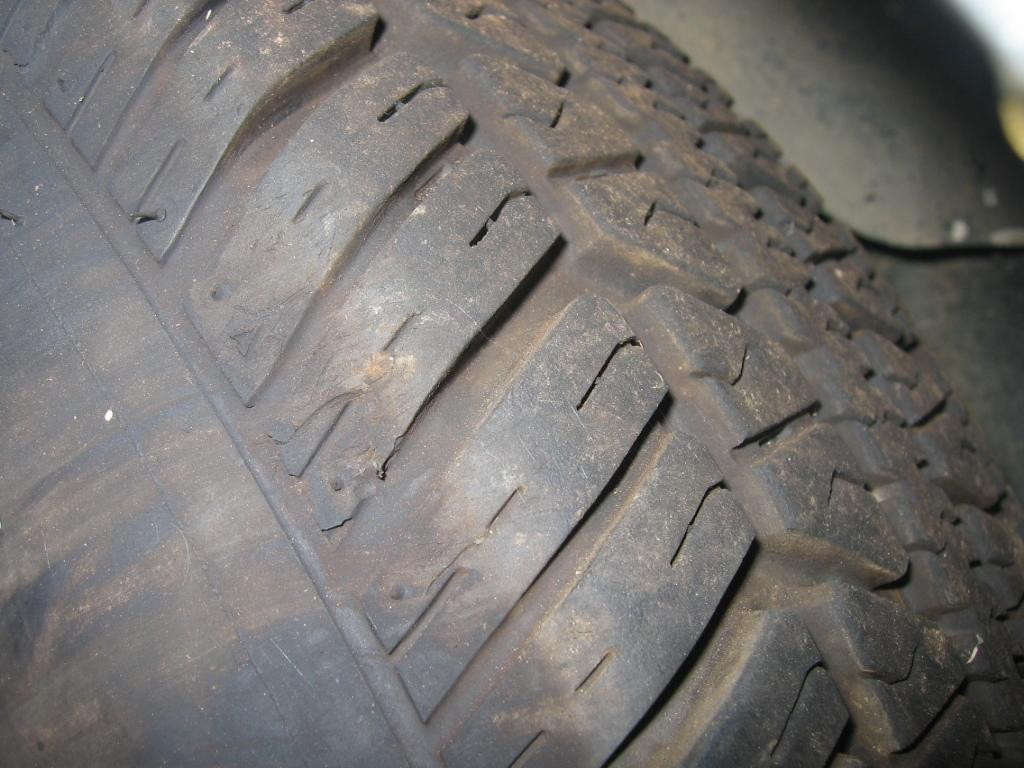What object is the main focus of the image? There is a black tire in the image. Can you describe any other details about the image? The top right corner of the image is blurred. What type of hose is connected to the carriage in the image? There is no hose or carriage present in the image; it only features a black tire. Where is the vacation destination shown in the image? There is no vacation destination shown in the image; it only features a black tire and a blurred top right corner. 